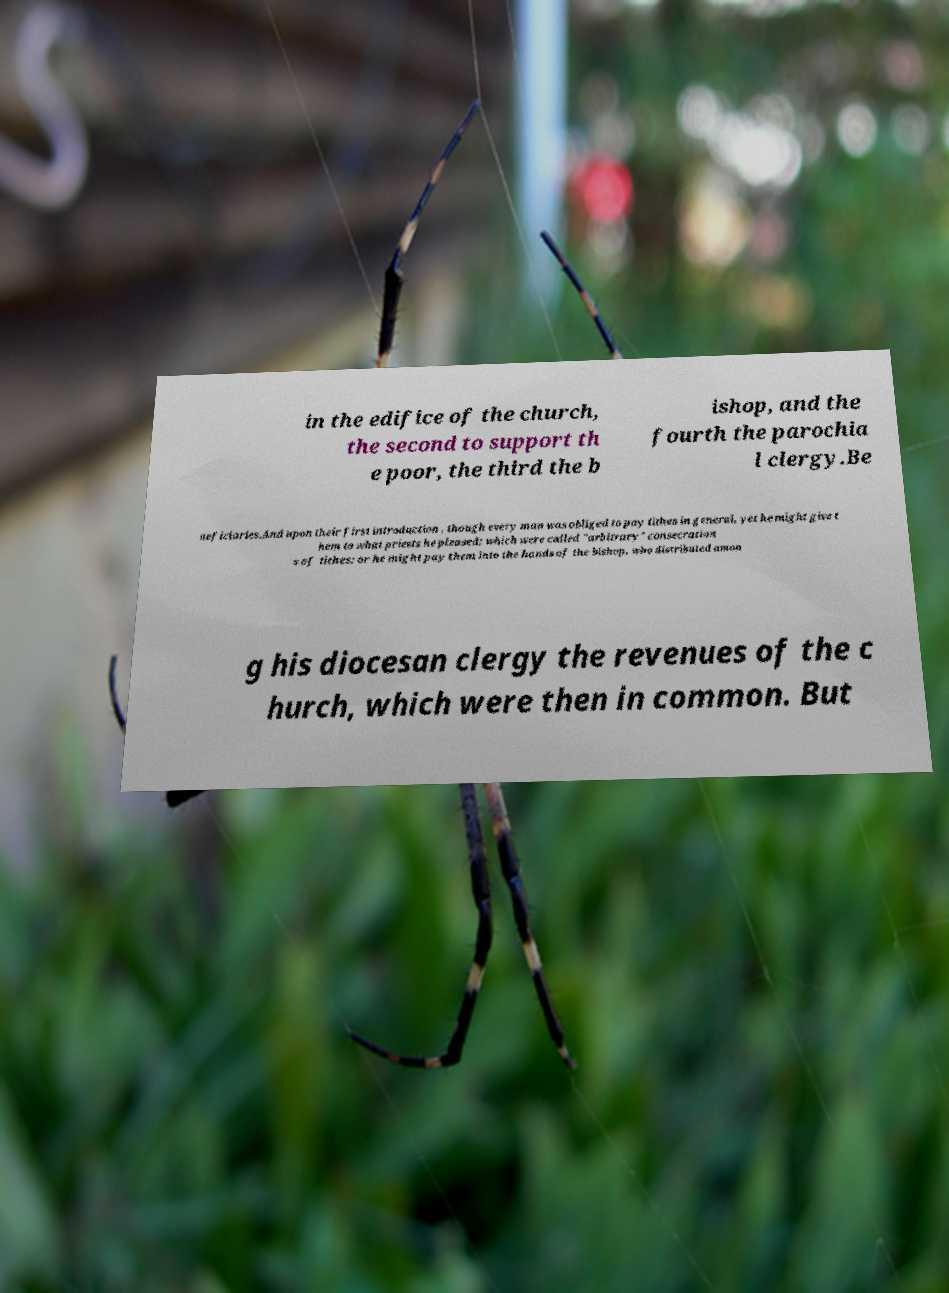Could you assist in decoding the text presented in this image and type it out clearly? in the edifice of the church, the second to support th e poor, the third the b ishop, and the fourth the parochia l clergy.Be neficiaries.And upon their first introduction , though every man was obliged to pay tithes in general, yet he might give t hem to what priests he pleased; which were called "arbitrary" consecration s of tithes: or he might pay them into the hands of the bishop, who distributed amon g his diocesan clergy the revenues of the c hurch, which were then in common. But 